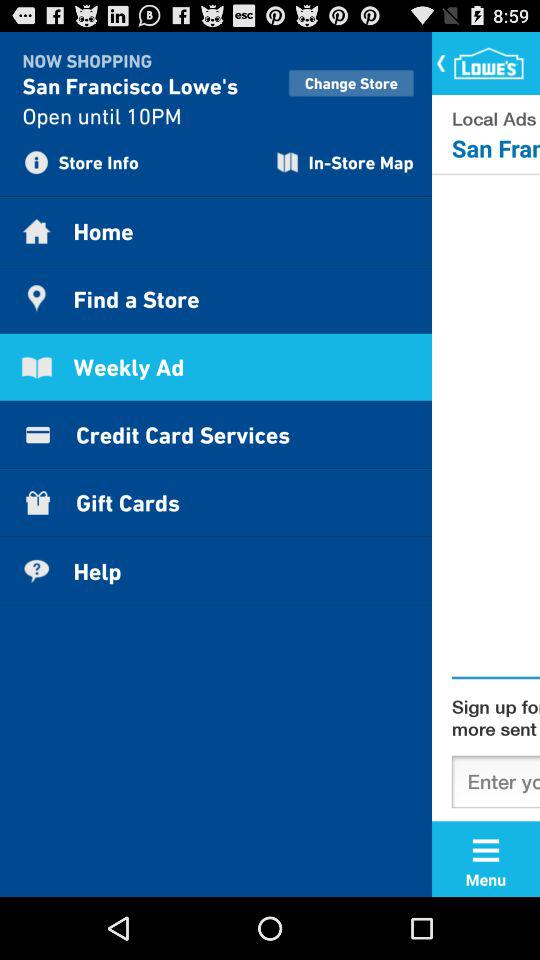What is the name of the shop? The name of the shop is "San Francisco Lowe's". 